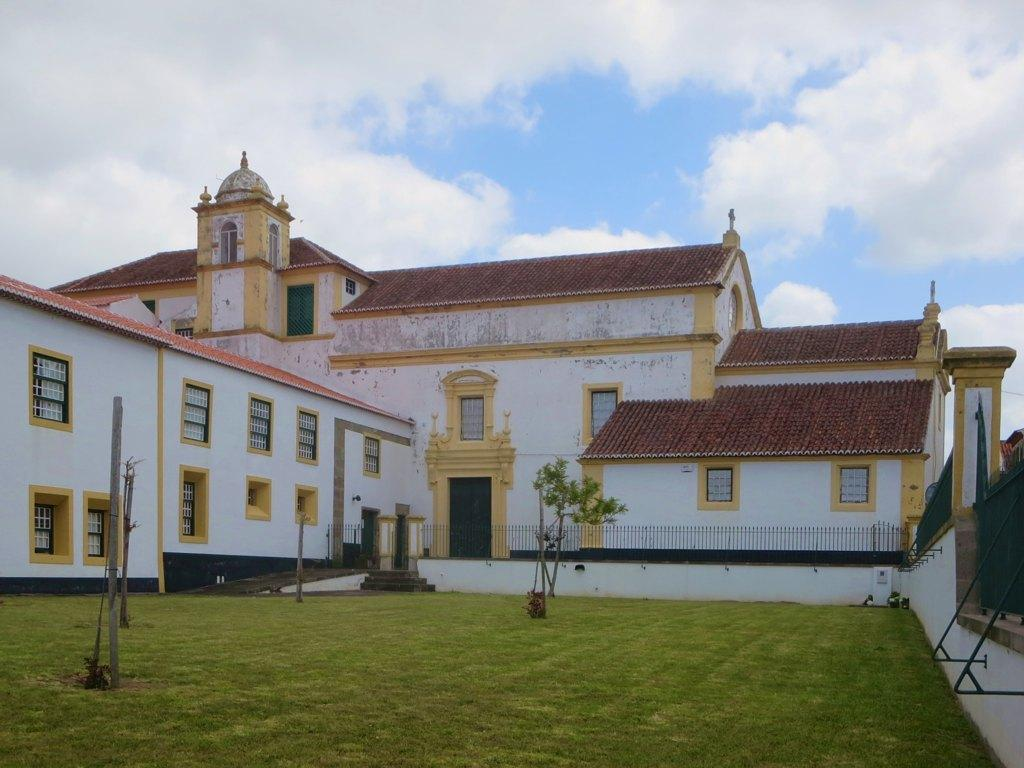What type of structure is visible in the image? There is a building in the image. What is the color of the grass on the ground in the image? The grass on the ground in the image is green. What can be seen in the sky in the image? There are clouds in the sky in the image. What type of tin is being used for addition in the image? There is no tin or addition present in the image. What type of crate can be seen in the image? There is no crate present in the image. 